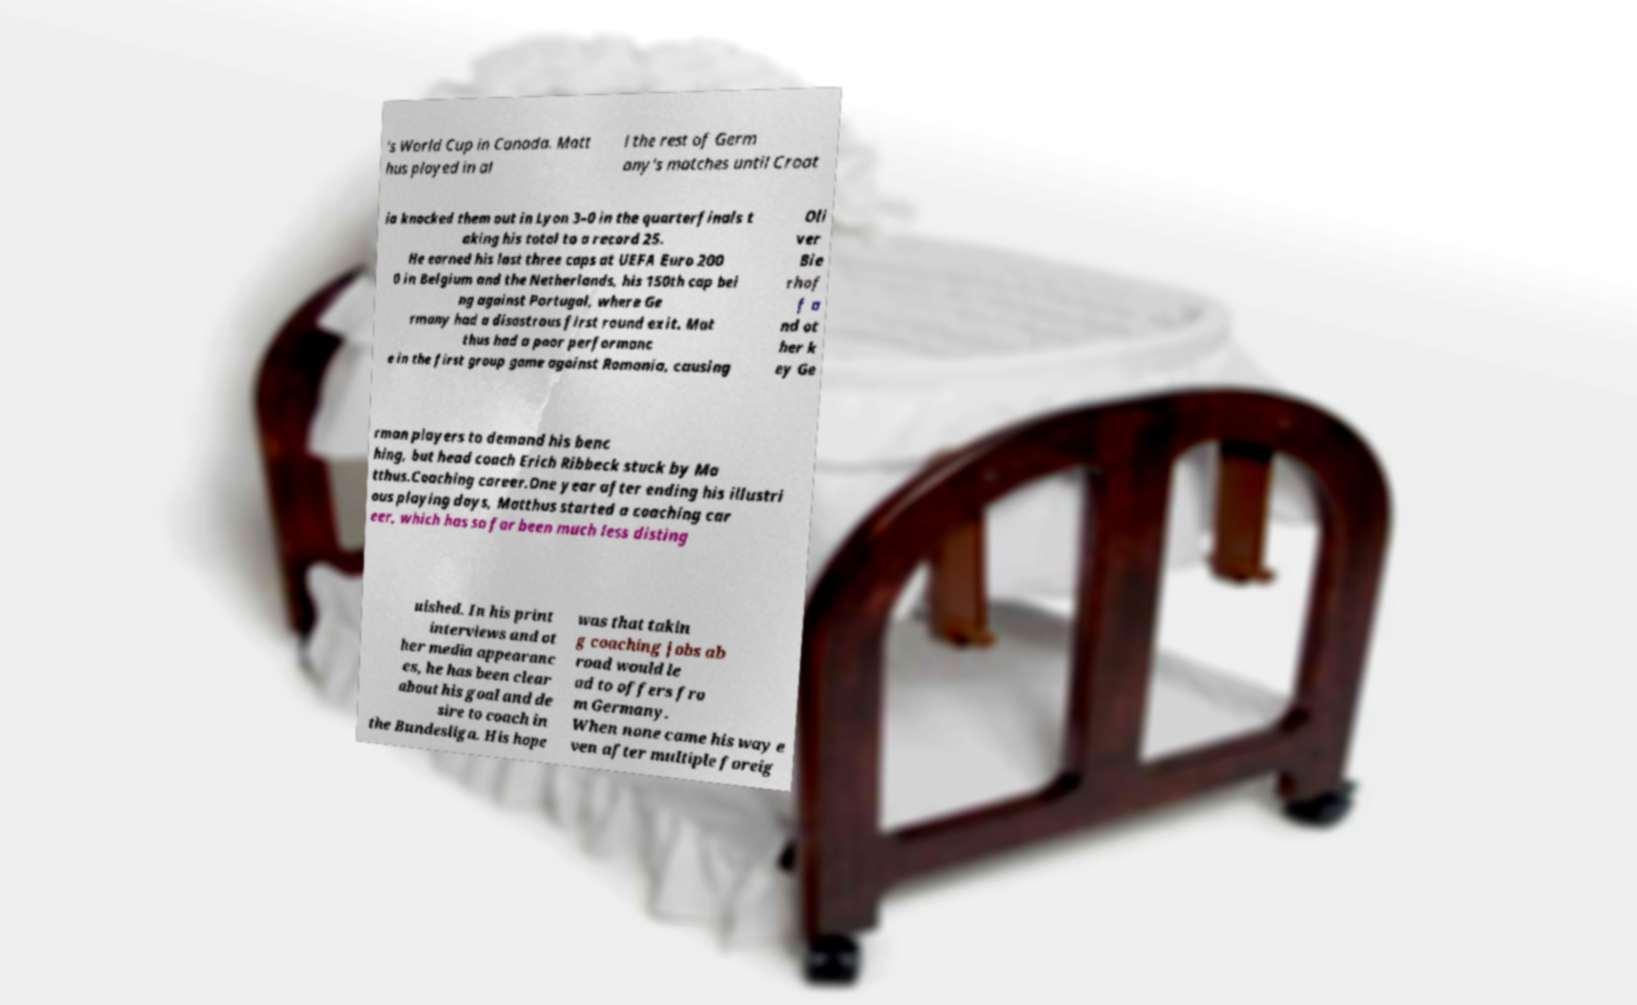There's text embedded in this image that I need extracted. Can you transcribe it verbatim? 's World Cup in Canada. Matt hus played in al l the rest of Germ any's matches until Croat ia knocked them out in Lyon 3–0 in the quarterfinals t aking his total to a record 25. He earned his last three caps at UEFA Euro 200 0 in Belgium and the Netherlands, his 150th cap bei ng against Portugal, where Ge rmany had a disastrous first round exit. Mat thus had a poor performanc e in the first group game against Romania, causing Oli ver Bie rhof f a nd ot her k ey Ge rman players to demand his benc hing, but head coach Erich Ribbeck stuck by Ma tthus.Coaching career.One year after ending his illustri ous playing days, Matthus started a coaching car eer, which has so far been much less disting uished. In his print interviews and ot her media appearanc es, he has been clear about his goal and de sire to coach in the Bundesliga. His hope was that takin g coaching jobs ab road would le ad to offers fro m Germany. When none came his way e ven after multiple foreig 